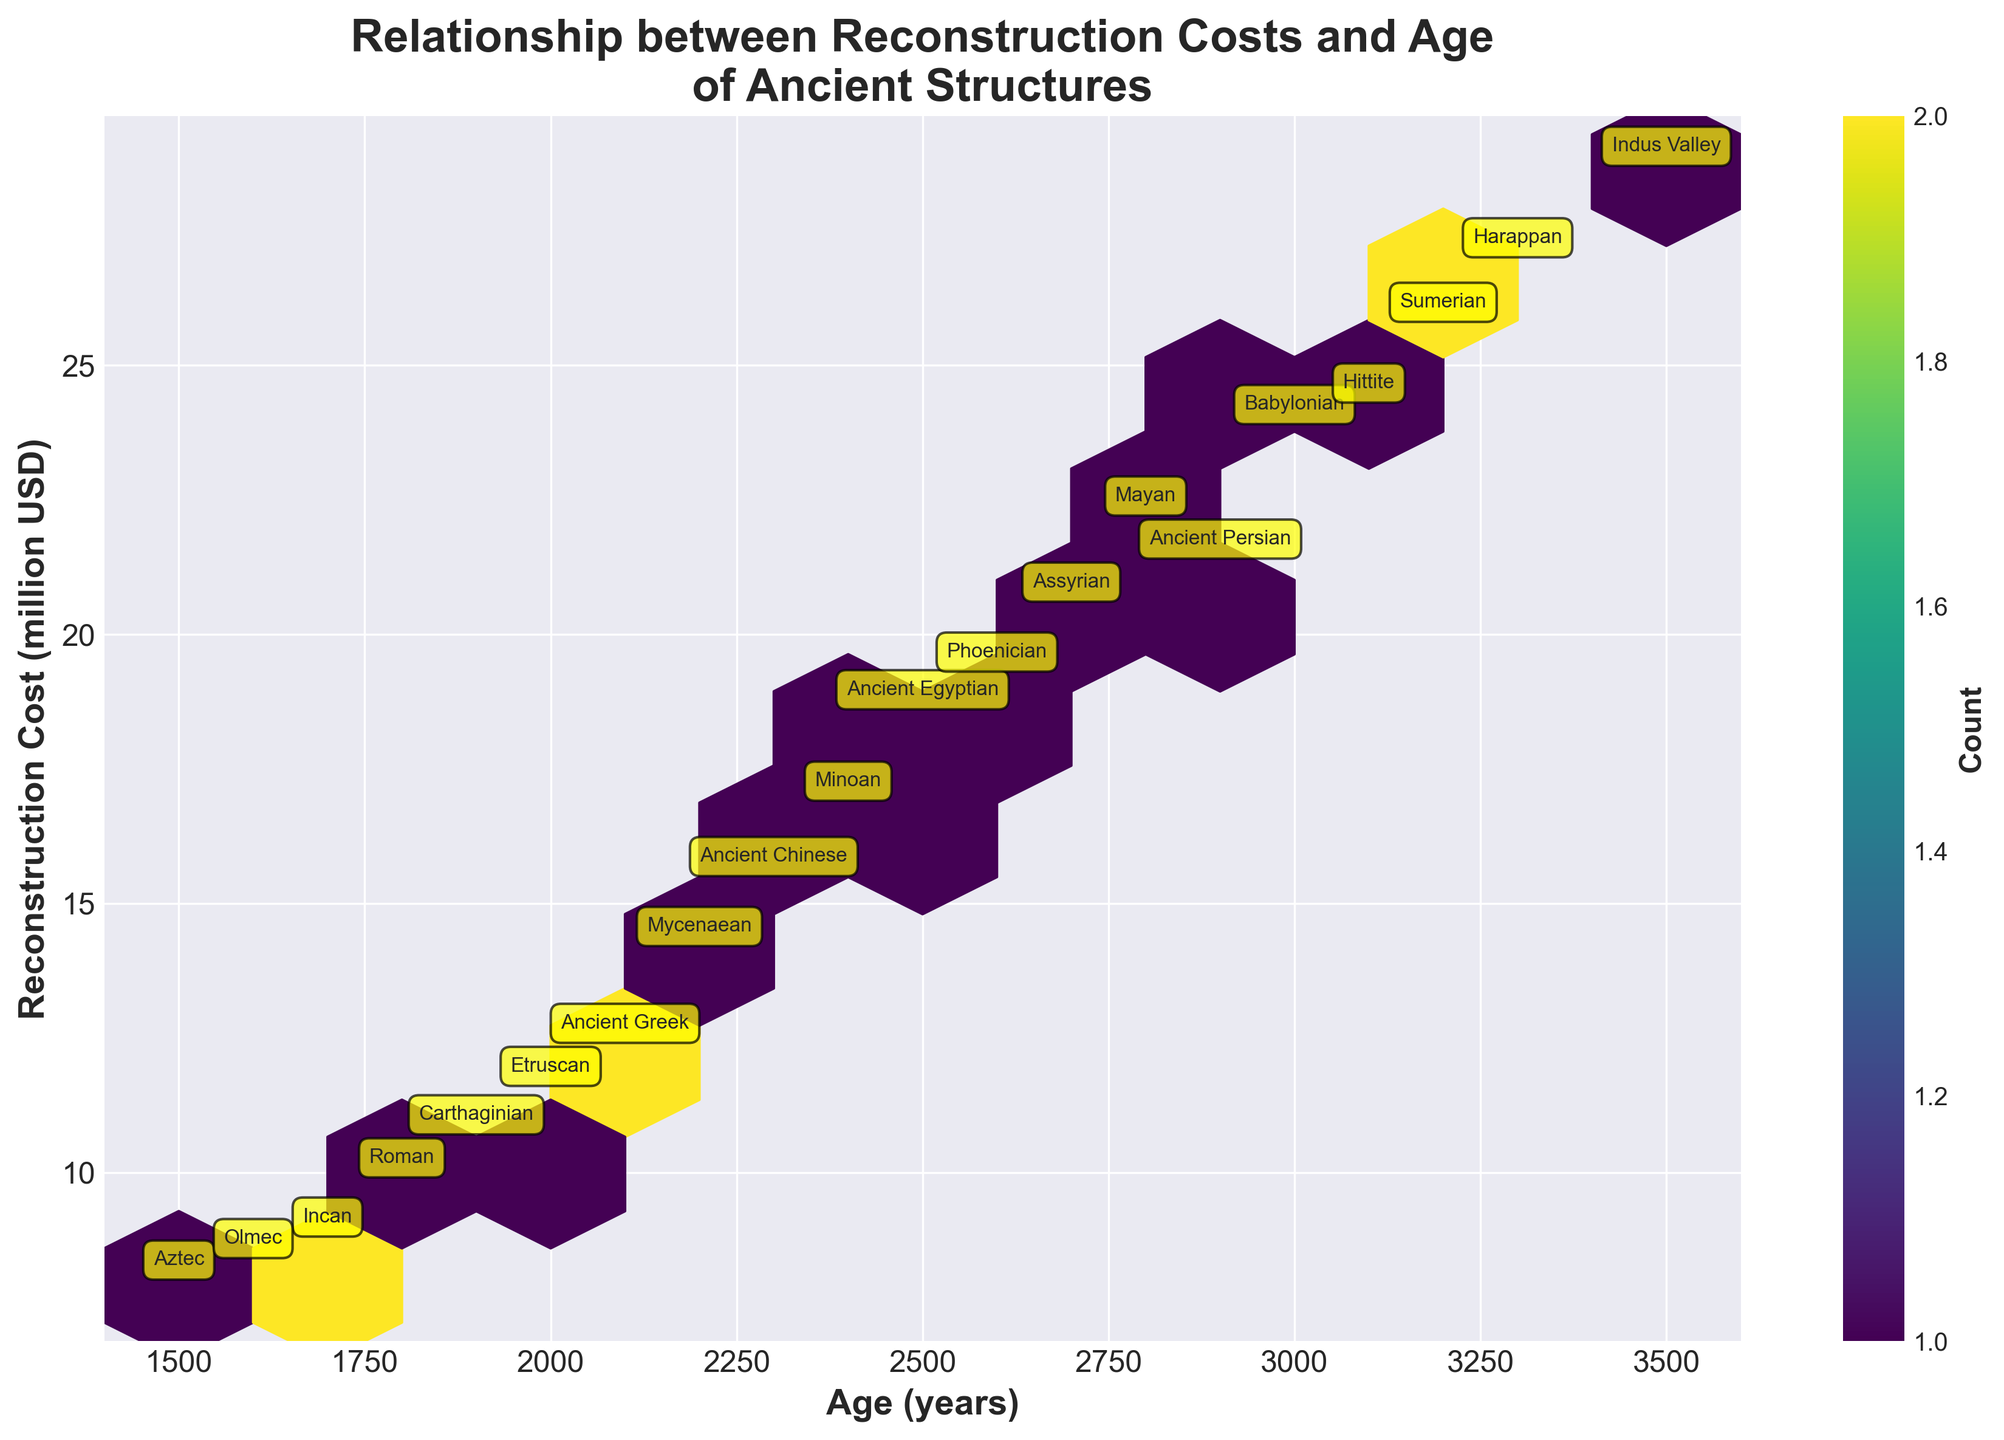How many data points are represented in the Hexbin plot? By observing the plot and understanding that each hexagon represents at least one data point (since mincnt=1), one can count the total number of unique structures represented. In this case, there are 20 hexagons, signifying 20 data points.
Answer: 20 What is the average reconstruction cost for structures older than 2500 years? To find the average, first identify the structures older than 2500 years. These are (3200, 25.7), (2800, 22.1), (3500, 28.6), (3000, 23.8), (2900, 21.3), (3300, 26.9). Summing the costs: 25.7 + 22.1 + 28.6 + 23.8 + 21.3 + 26.9 = 148.4. Dividing by the number of data points (6) gives the average: 148.4 / 6 = 24.73.
Answer: 24.73 Which structure has the lowest reconstruction cost, and what is its corresponding civilization? The plot annotations indicate that the Aztec structure has the lowest reconstruction cost of 7.9 million USD.
Answer: Aztec, 7.9 Are there any civilizations with structures both younger than 2000 years and older than 3000 years represented in the plot? By looking at the age and the civilizations in the plot annotations, we find that no single civilization spans both age ranges (younger than 2000 years and older than 3000 years).
Answer: No Which two civilizations have the closest reconstruction costs, and what are their costs? By comparing the reconstruction costs in the plot annotations, we see that the Roman (9.8 million USD) and Carthaginian (10.6 million USD) structures have the closest costs, with a difference of just 0.8 million USD.
Answer: Roman (9.8) and Carthaginian (10.6) What is the main trend observed between the age of structures and reconstruction costs? The Hexbin plot shows a general trend where older structures tend to have higher reconstruction costs, as indicated by darker hexagons clustering towards higher ages and costs.
Answer: Older structures, higher costs Is there any civilization with multiple data points falling in the same hexbin? Binning in the Hexbin plot might aggregate multiple data points into the same hexagon. Observing the annotations, no civilization appears to have multiple entries falling within the exact same bin.
Answer: No Which civilization has the highest reconstruction cost, and what is its age? The Indus Valley civilization has the highest reconstruction cost, with a value of 28.6 million USD, and its structure is 3500 years old.
Answer: Indus Valley, 3500 years 